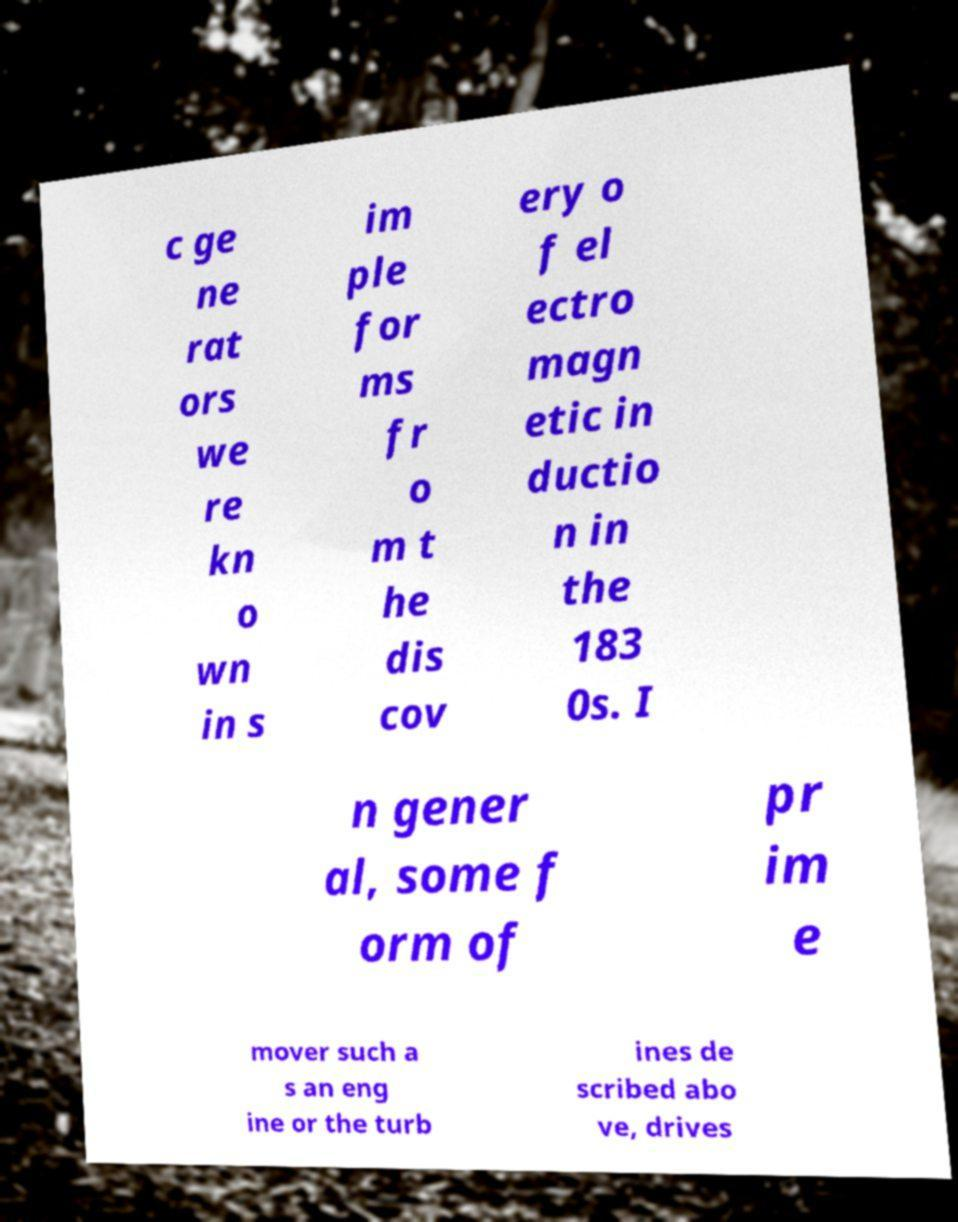I need the written content from this picture converted into text. Can you do that? c ge ne rat ors we re kn o wn in s im ple for ms fr o m t he dis cov ery o f el ectro magn etic in ductio n in the 183 0s. I n gener al, some f orm of pr im e mover such a s an eng ine or the turb ines de scribed abo ve, drives 